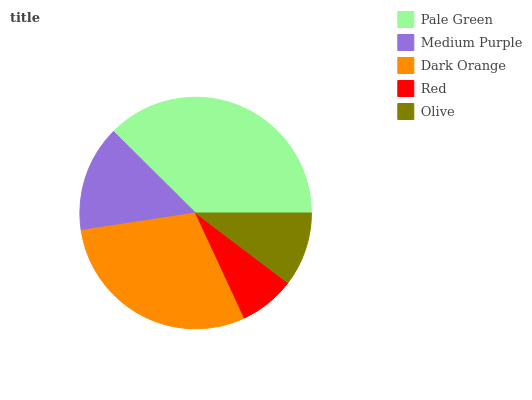Is Red the minimum?
Answer yes or no. Yes. Is Pale Green the maximum?
Answer yes or no. Yes. Is Medium Purple the minimum?
Answer yes or no. No. Is Medium Purple the maximum?
Answer yes or no. No. Is Pale Green greater than Medium Purple?
Answer yes or no. Yes. Is Medium Purple less than Pale Green?
Answer yes or no. Yes. Is Medium Purple greater than Pale Green?
Answer yes or no. No. Is Pale Green less than Medium Purple?
Answer yes or no. No. Is Medium Purple the high median?
Answer yes or no. Yes. Is Medium Purple the low median?
Answer yes or no. Yes. Is Red the high median?
Answer yes or no. No. Is Olive the low median?
Answer yes or no. No. 